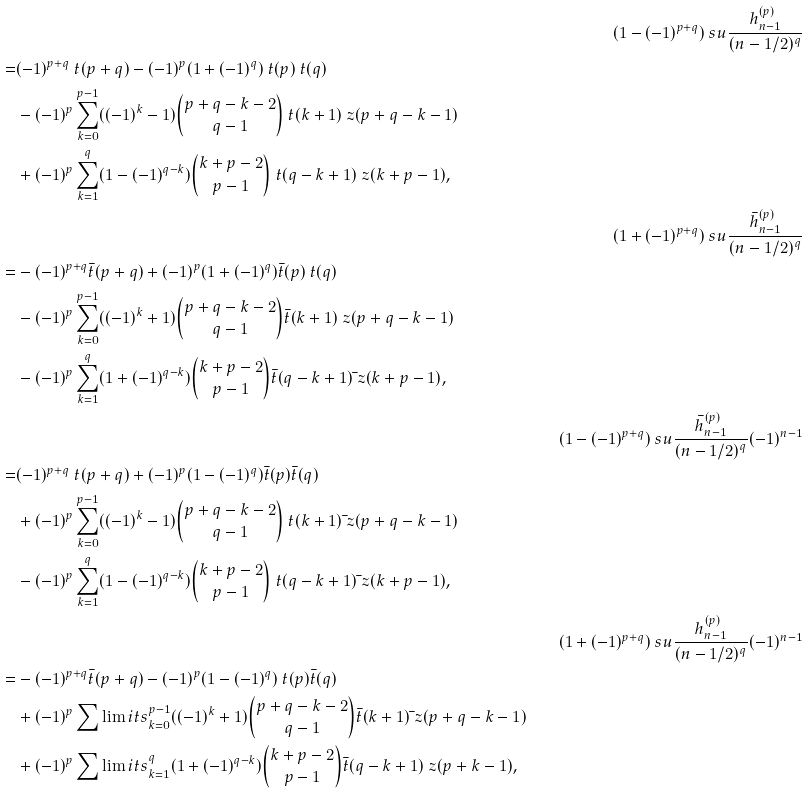<formula> <loc_0><loc_0><loc_500><loc_500>& & ( 1 - ( - 1 ) ^ { p + q } ) \ s u \frac { h ^ { ( p ) } _ { n - 1 } } { ( n - 1 / 2 ) ^ { q } } \\ = & ( - 1 ) ^ { p + q } \ t ( p + q ) - ( - 1 ) ^ { p } ( 1 + ( - 1 ) ^ { q } ) \ t ( p ) \ t ( q ) \\ & - ( - 1 ) ^ { p } \sum _ { k = 0 } ^ { p - 1 } ( ( - 1 ) ^ { k } - 1 ) \binom { p + q - k - 2 } { q - 1 } \ t ( k + 1 ) \ z ( p + q - k - 1 ) \\ & + ( - 1 ) ^ { p } \sum _ { k = 1 } ^ { q } ( 1 - ( - 1 ) ^ { q - k } ) \binom { k + p - 2 } { p - 1 } \ t ( q - k + 1 ) \ z ( k + p - 1 ) , \\ & & ( 1 + ( - 1 ) ^ { p + q } ) \ s u \frac { { \bar { h } } ^ { ( p ) } _ { n - 1 } } { ( n - 1 / 2 ) ^ { q } } \\ = & - ( - 1 ) ^ { p + q } { \bar { t } } ( p + q ) + ( - 1 ) ^ { p } ( 1 + ( - 1 ) ^ { q } ) { \bar { t } } ( p ) \ t ( q ) \\ & - ( - 1 ) ^ { p } \sum _ { k = 0 } ^ { p - 1 } ( ( - 1 ) ^ { k } + 1 ) \binom { p + q - k - 2 } { q - 1 } { \bar { t } } ( k + 1 ) \ z ( p + q - k - 1 ) \\ & - ( - 1 ) ^ { p } \sum _ { k = 1 } ^ { q } ( 1 + ( - 1 ) ^ { q - k } ) \binom { k + p - 2 } { p - 1 } { \bar { t } } ( q - k + 1 ) { \bar { \ } z } ( k + p - 1 ) , \\ & & ( 1 - ( - 1 ) ^ { p + q } ) \ s u \frac { { \bar { h } } ^ { ( p ) } _ { n - 1 } } { ( n - 1 / 2 ) ^ { q } } ( - 1 ) ^ { n - 1 } \\ = & ( - 1 ) ^ { p + q } \ t ( p + q ) + ( - 1 ) ^ { p } ( 1 - ( - 1 ) ^ { q } ) { \bar { t } } ( p ) { \bar { t } } ( q ) \\ & + ( - 1 ) ^ { p } \sum _ { k = 0 } ^ { p - 1 } ( ( - 1 ) ^ { k } - 1 ) \binom { p + q - k - 2 } { q - 1 } \ t ( k + 1 ) { \bar { \ } z } ( p + q - k - 1 ) \\ & - ( - 1 ) ^ { p } \sum _ { k = 1 } ^ { q } ( 1 - ( - 1 ) ^ { q - k } ) \binom { k + p - 2 } { p - 1 } \ t ( q - k + 1 ) { \bar { \ } z } ( k + p - 1 ) , & \\ & & ( 1 + ( - 1 ) ^ { p + q } ) \ s u \frac { { h } ^ { ( p ) } _ { n - 1 } } { ( n - 1 / 2 ) ^ { q } } ( - 1 ) ^ { n - 1 } \\ = & - ( - 1 ) ^ { p + q } { \bar { t } } ( p + q ) - ( - 1 ) ^ { p } ( 1 - ( - 1 ) ^ { q } ) \ t ( p ) { \bar { t } } ( q ) \\ & + ( - 1 ) ^ { p } \sum \lim i t s _ { k = 0 } ^ { p - 1 } ( ( - 1 ) ^ { k } + 1 ) \binom { p + q - k - 2 } { q - 1 } { \bar { t } } ( k + 1 ) { \bar { \ } z } ( { p + q - k - 1 } ) \\ & + ( - 1 ) ^ { p } \sum \lim i t s _ { k = 1 } ^ { q } ( 1 + ( - 1 ) ^ { q - k } ) \binom { k + p - 2 } { p - 1 } { \bar { t } } ( q - k + 1 ) \ z ( p + k - 1 ) ,</formula> 